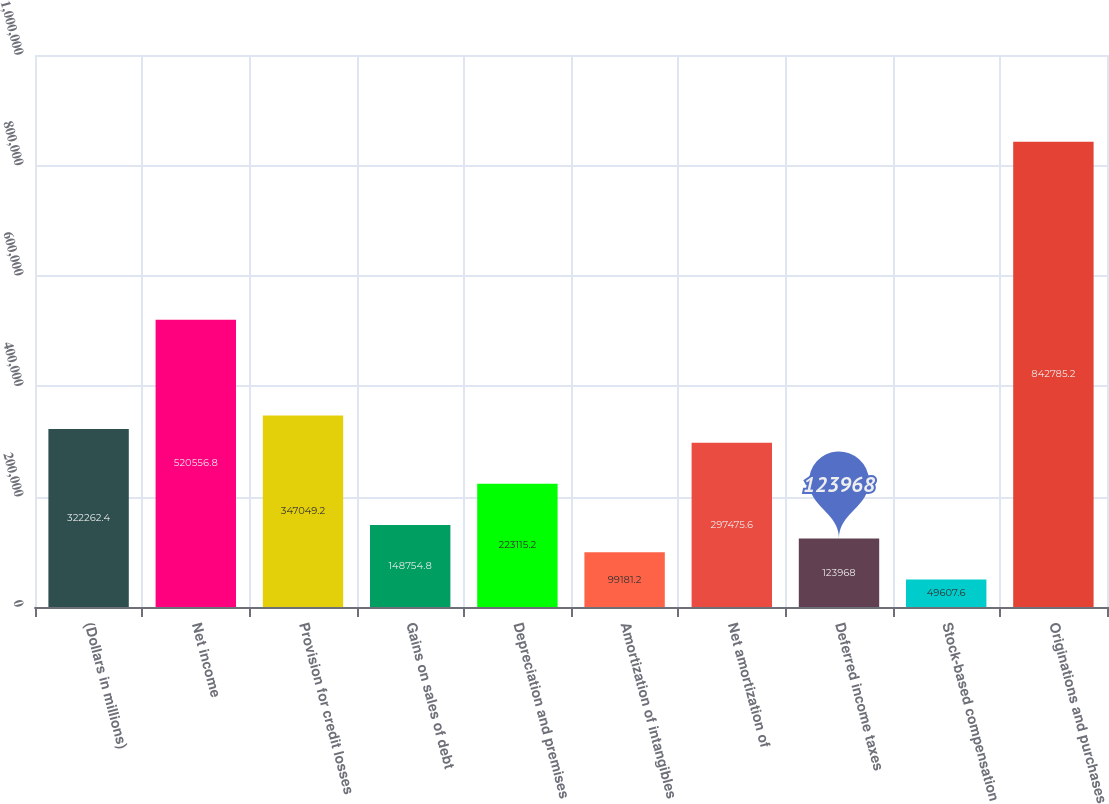Convert chart. <chart><loc_0><loc_0><loc_500><loc_500><bar_chart><fcel>(Dollars in millions)<fcel>Net income<fcel>Provision for credit losses<fcel>Gains on sales of debt<fcel>Depreciation and premises<fcel>Amortization of intangibles<fcel>Net amortization of<fcel>Deferred income taxes<fcel>Stock-based compensation<fcel>Originations and purchases<nl><fcel>322262<fcel>520557<fcel>347049<fcel>148755<fcel>223115<fcel>99181.2<fcel>297476<fcel>123968<fcel>49607.6<fcel>842785<nl></chart> 